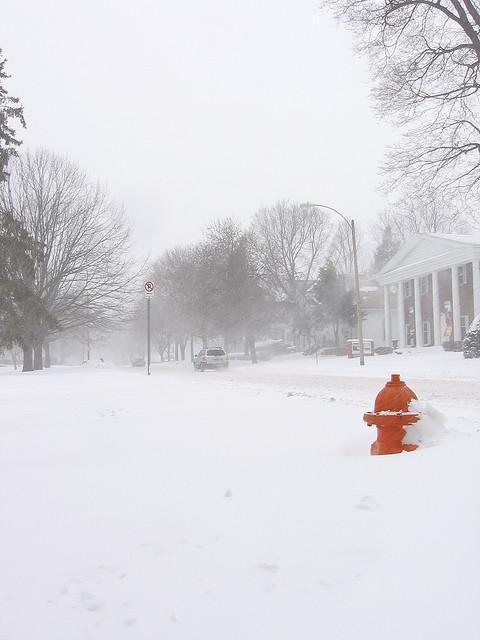How many pillars are on the building?
Give a very brief answer. 6. 